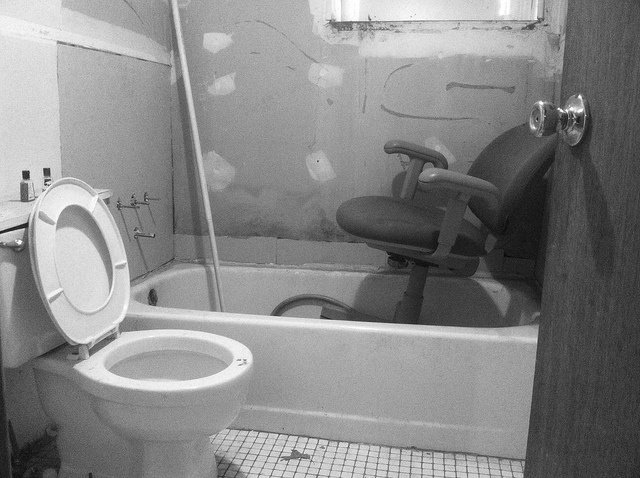Describe the objects in this image and their specific colors. I can see toilet in lightgray, darkgray, gray, and black tones, chair in lightgray, gray, and black tones, bottle in lightgray, gray, darkgray, and black tones, and bottle in lightgray, gray, darkgray, and black tones in this image. 